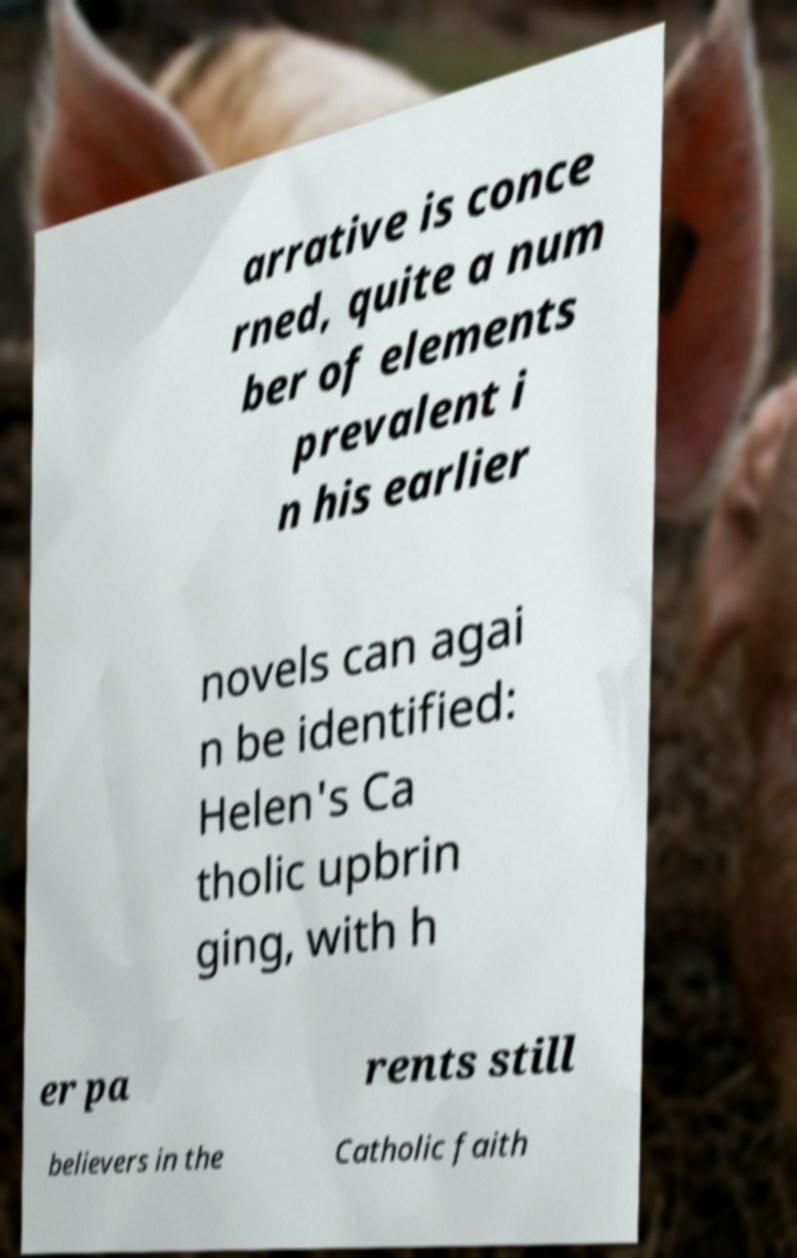What messages or text are displayed in this image? I need them in a readable, typed format. arrative is conce rned, quite a num ber of elements prevalent i n his earlier novels can agai n be identified: Helen's Ca tholic upbrin ging, with h er pa rents still believers in the Catholic faith 